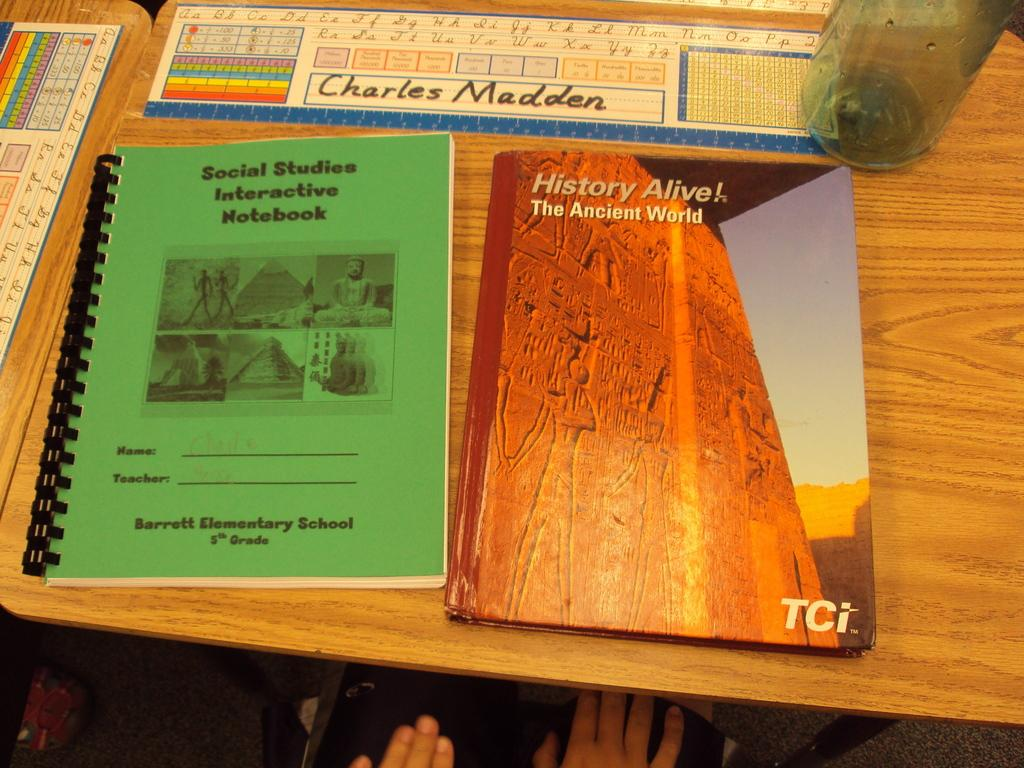<image>
Describe the image concisely. A schoolbook titled "History Alive!" sitting on a desk. 